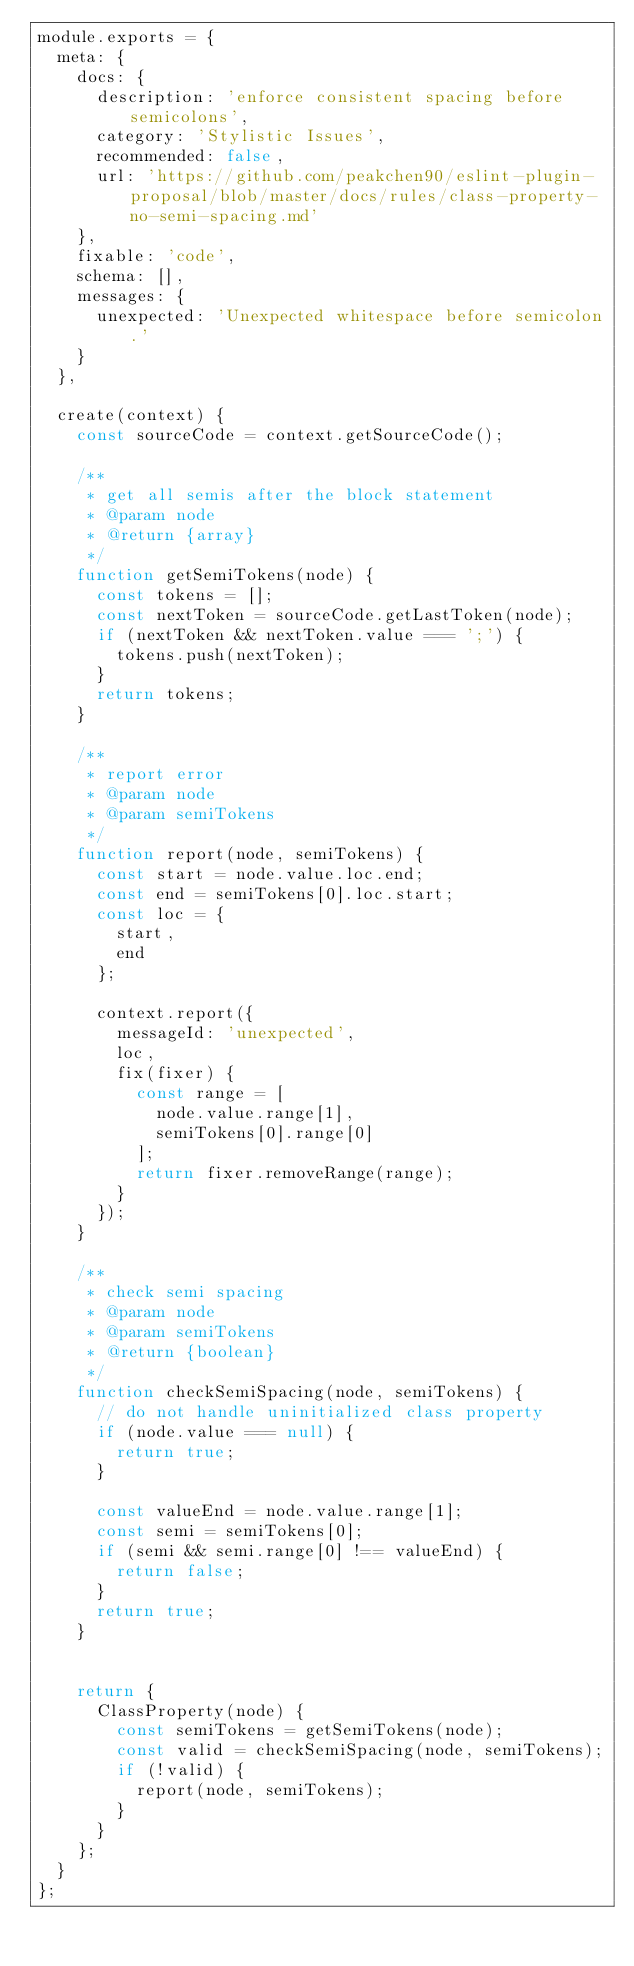Convert code to text. <code><loc_0><loc_0><loc_500><loc_500><_JavaScript_>module.exports = {
  meta: {
    docs: {
      description: 'enforce consistent spacing before semicolons',
      category: 'Stylistic Issues',
      recommended: false,
      url: 'https://github.com/peakchen90/eslint-plugin-proposal/blob/master/docs/rules/class-property-no-semi-spacing.md'
    },
    fixable: 'code',
    schema: [],
    messages: {
      unexpected: 'Unexpected whitespace before semicolon.'
    }
  },

  create(context) {
    const sourceCode = context.getSourceCode();

    /**
     * get all semis after the block statement
     * @param node
     * @return {array}
     */
    function getSemiTokens(node) {
      const tokens = [];
      const nextToken = sourceCode.getLastToken(node);
      if (nextToken && nextToken.value === ';') {
        tokens.push(nextToken);
      }
      return tokens;
    }

    /**
     * report error
     * @param node
     * @param semiTokens
     */
    function report(node, semiTokens) {
      const start = node.value.loc.end;
      const end = semiTokens[0].loc.start;
      const loc = {
        start,
        end
      };

      context.report({
        messageId: 'unexpected',
        loc,
        fix(fixer) {
          const range = [
            node.value.range[1],
            semiTokens[0].range[0]
          ];
          return fixer.removeRange(range);
        }
      });
    }

    /**
     * check semi spacing
     * @param node
     * @param semiTokens
     * @return {boolean}
     */
    function checkSemiSpacing(node, semiTokens) {
      // do not handle uninitialized class property
      if (node.value === null) {
        return true;
      }

      const valueEnd = node.value.range[1];
      const semi = semiTokens[0];
      if (semi && semi.range[0] !== valueEnd) {
        return false;
      }
      return true;
    }


    return {
      ClassProperty(node) {
        const semiTokens = getSemiTokens(node);
        const valid = checkSemiSpacing(node, semiTokens);
        if (!valid) {
          report(node, semiTokens);
        }
      }
    };
  }
};
</code> 